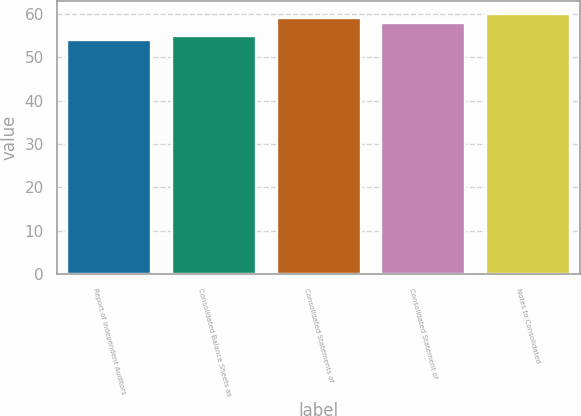<chart> <loc_0><loc_0><loc_500><loc_500><bar_chart><fcel>Report of Independent Auditors<fcel>Consolidated Balance Sheets as<fcel>Consolidated Statements of<fcel>Consolidated Statement of<fcel>Notes to Consolidated<nl><fcel>54<fcel>55<fcel>59<fcel>58<fcel>60<nl></chart> 